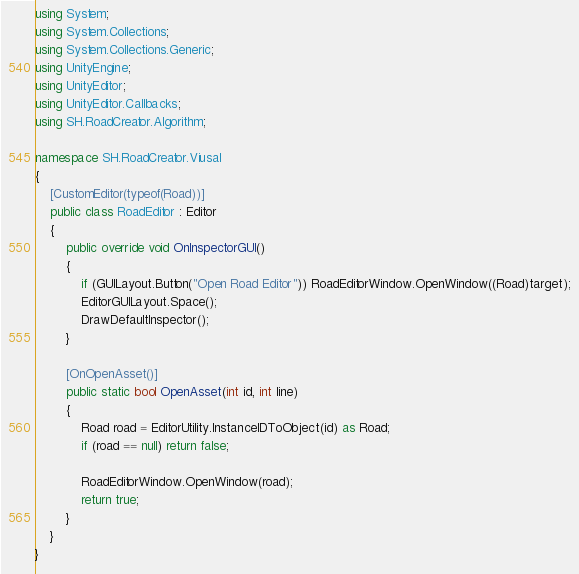Convert code to text. <code><loc_0><loc_0><loc_500><loc_500><_C#_>using System;
using System.Collections;
using System.Collections.Generic;
using UnityEngine;
using UnityEditor;
using UnityEditor.Callbacks;
using SH.RoadCreator.Algorithm;

namespace SH.RoadCreator.Viusal
{
    [CustomEditor(typeof(Road))]
    public class RoadEditor : Editor
    {
        public override void OnInspectorGUI()
        {
            if (GUILayout.Button("Open Road Editor")) RoadEditorWindow.OpenWindow((Road)target);
            EditorGUILayout.Space();
            DrawDefaultInspector();
        }

        [OnOpenAsset()]
        public static bool OpenAsset(int id, int line)
        {
            Road road = EditorUtility.InstanceIDToObject(id) as Road;
            if (road == null) return false;

            RoadEditorWindow.OpenWindow(road);
            return true;
        }
    }
}</code> 